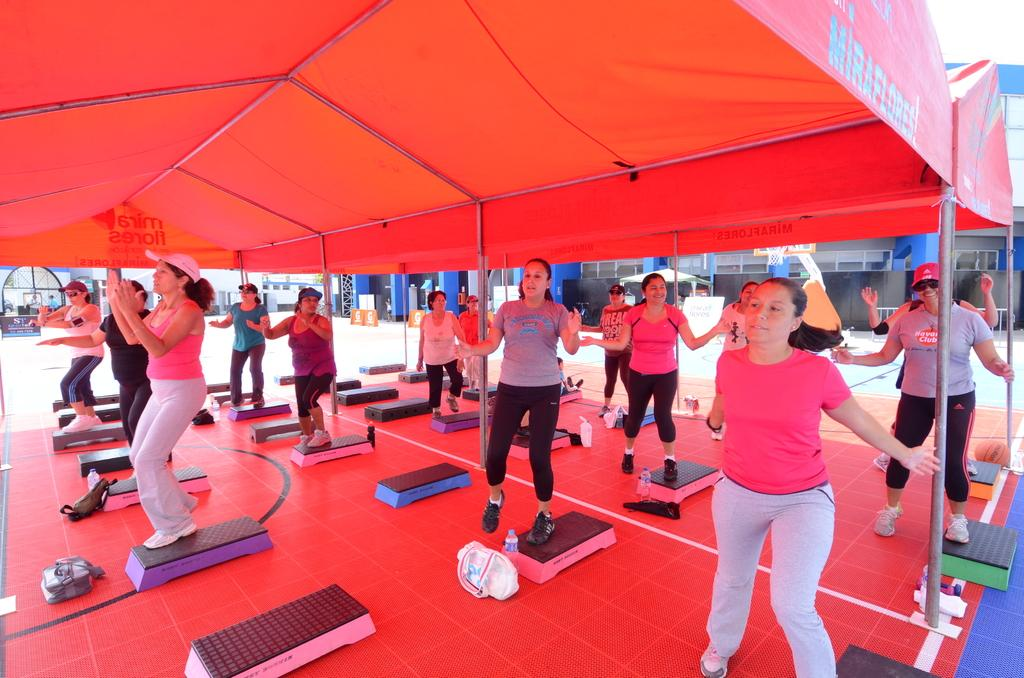What are the people in the image doing? The people in the image are doing exercise. What can be seen in the background of the image? There is a blue building in the background of the image. What is the overall color tone of the image? There is a white tint in the image. What color is the roof of the building in the front of the image? There is a red roof in the front of the image. What type of amusement can be seen in the image? There is no amusement present in the image; it features a group of people exercising. How many pies are visible in the image? There are no pies present in the image. 